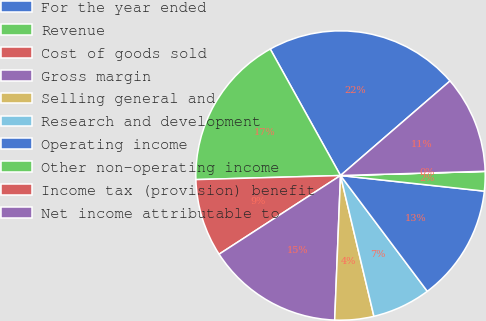Convert chart. <chart><loc_0><loc_0><loc_500><loc_500><pie_chart><fcel>For the year ended<fcel>Revenue<fcel>Cost of goods sold<fcel>Gross margin<fcel>Selling general and<fcel>Research and development<fcel>Operating income<fcel>Other non-operating income<fcel>Income tax (provision) benefit<fcel>Net income attributable to<nl><fcel>21.73%<fcel>17.38%<fcel>8.7%<fcel>15.21%<fcel>4.35%<fcel>6.53%<fcel>13.04%<fcel>2.18%<fcel>0.01%<fcel>10.87%<nl></chart> 